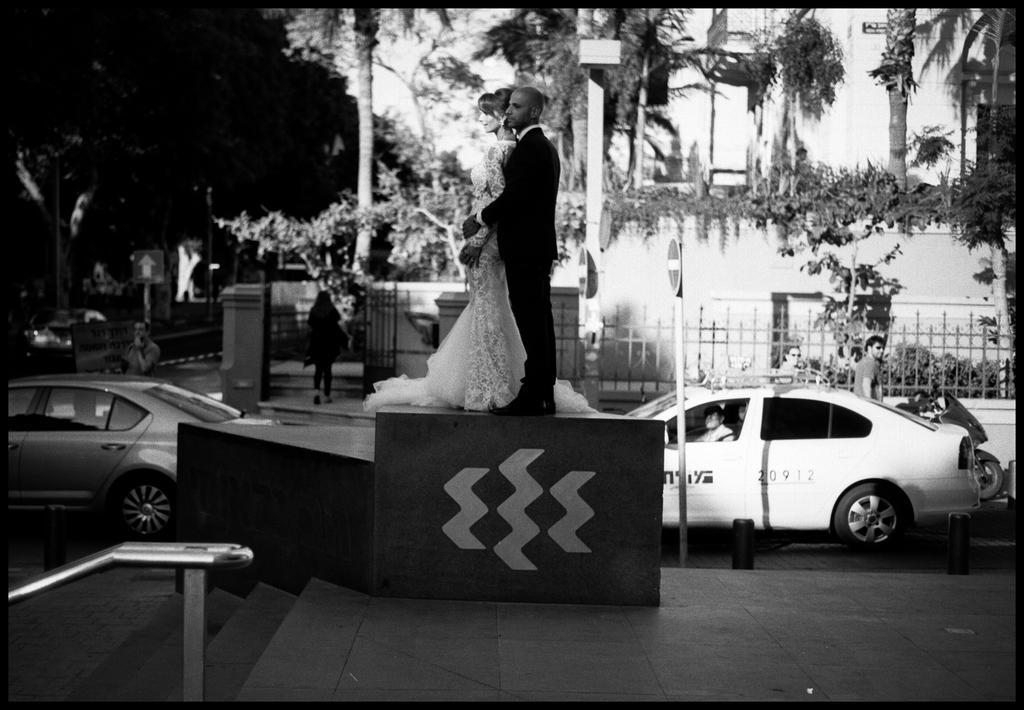In one or two sentences, can you explain what this image depicts? In this picture we can see rod, steps and there are two people standing on the platform. We can see boards, poles and vehicles on the road. In the background of the image we can see people, plants, trees, fence, building and sky. 